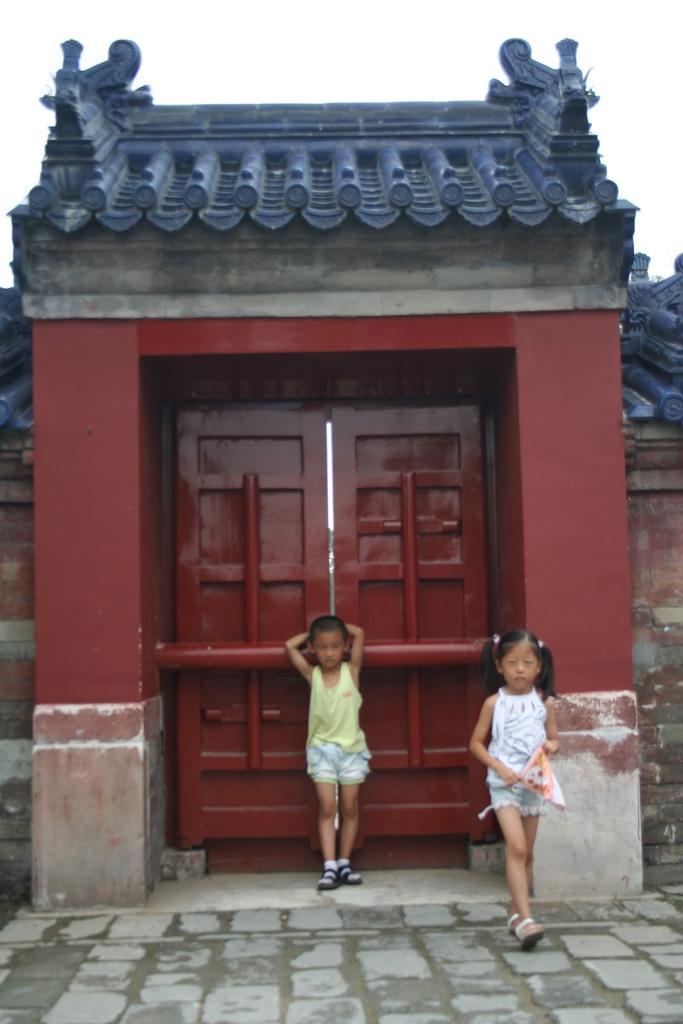Can you describe this image briefly? In this picture I can see a door in front of it two kids are standing. 